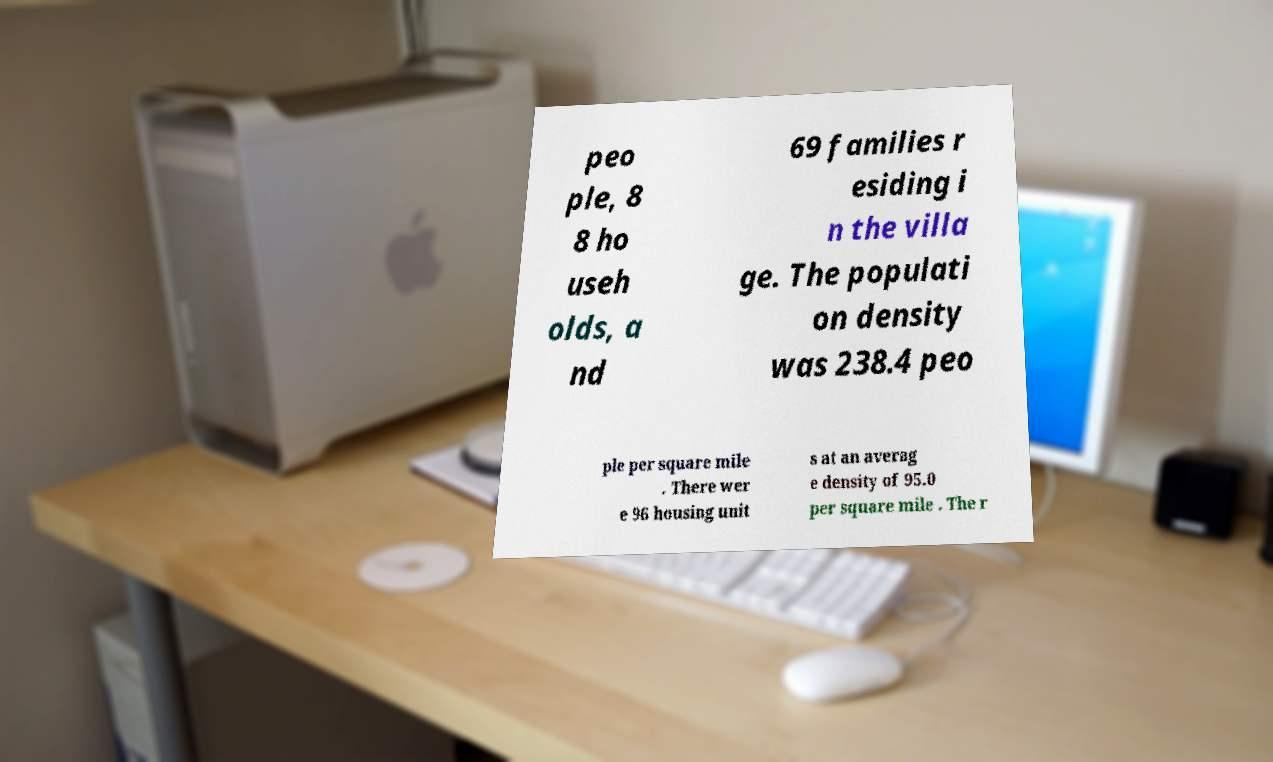There's text embedded in this image that I need extracted. Can you transcribe it verbatim? peo ple, 8 8 ho useh olds, a nd 69 families r esiding i n the villa ge. The populati on density was 238.4 peo ple per square mile . There wer e 96 housing unit s at an averag e density of 95.0 per square mile . The r 